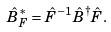<formula> <loc_0><loc_0><loc_500><loc_500>\hat { B } _ { F } ^ { \ast } = \hat { F } ^ { - 1 } \hat { B } ^ { \dag } \hat { F } .</formula> 